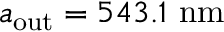Convert formula to latex. <formula><loc_0><loc_0><loc_500><loc_500>a _ { o u t } = 5 4 3 . 1 \ n m</formula> 